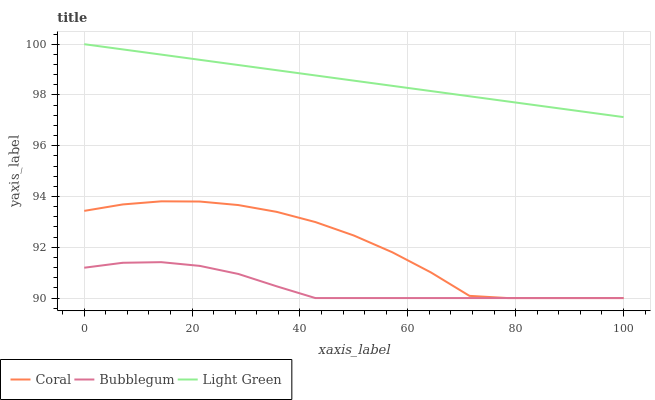Does Bubblegum have the minimum area under the curve?
Answer yes or no. Yes. Does Light Green have the maximum area under the curve?
Answer yes or no. Yes. Does Light Green have the minimum area under the curve?
Answer yes or no. No. Does Bubblegum have the maximum area under the curve?
Answer yes or no. No. Is Light Green the smoothest?
Answer yes or no. Yes. Is Coral the roughest?
Answer yes or no. Yes. Is Bubblegum the smoothest?
Answer yes or no. No. Is Bubblegum the roughest?
Answer yes or no. No. Does Light Green have the lowest value?
Answer yes or no. No. Does Bubblegum have the highest value?
Answer yes or no. No. Is Coral less than Light Green?
Answer yes or no. Yes. Is Light Green greater than Bubblegum?
Answer yes or no. Yes. Does Coral intersect Light Green?
Answer yes or no. No. 